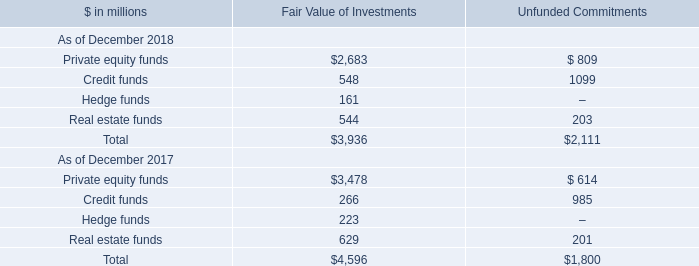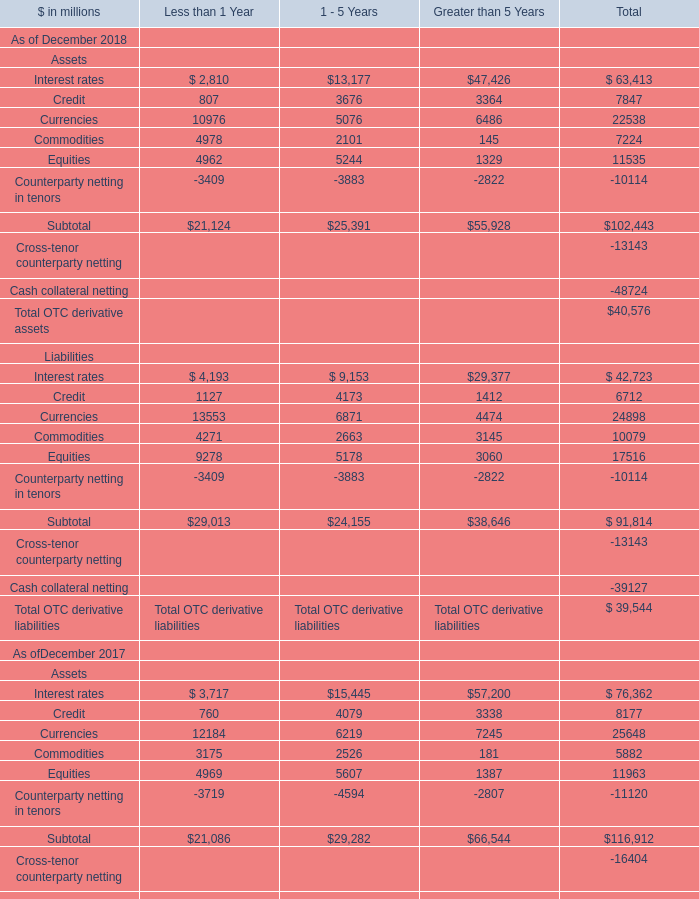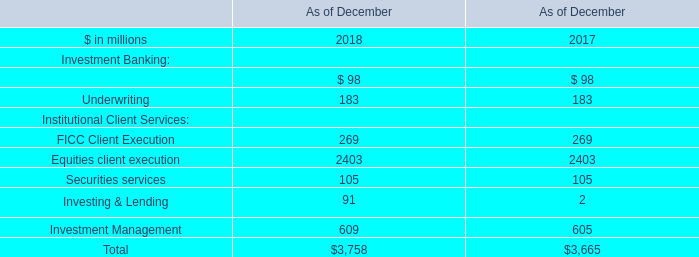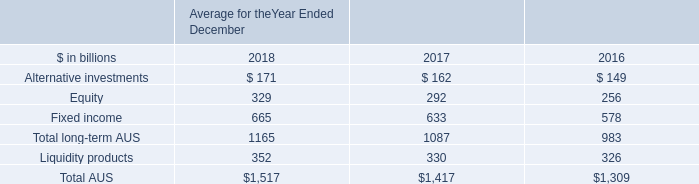What was the total amount of Assets excluding those Assets in total greater than 10000 in 2018 ? (in million) 
Computations: ((63413 + 22538) + 11535)
Answer: 97486.0. 